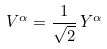Convert formula to latex. <formula><loc_0><loc_0><loc_500><loc_500>V ^ { \alpha } = \frac { 1 } { \sqrt { 2 } } \, Y ^ { \alpha }</formula> 